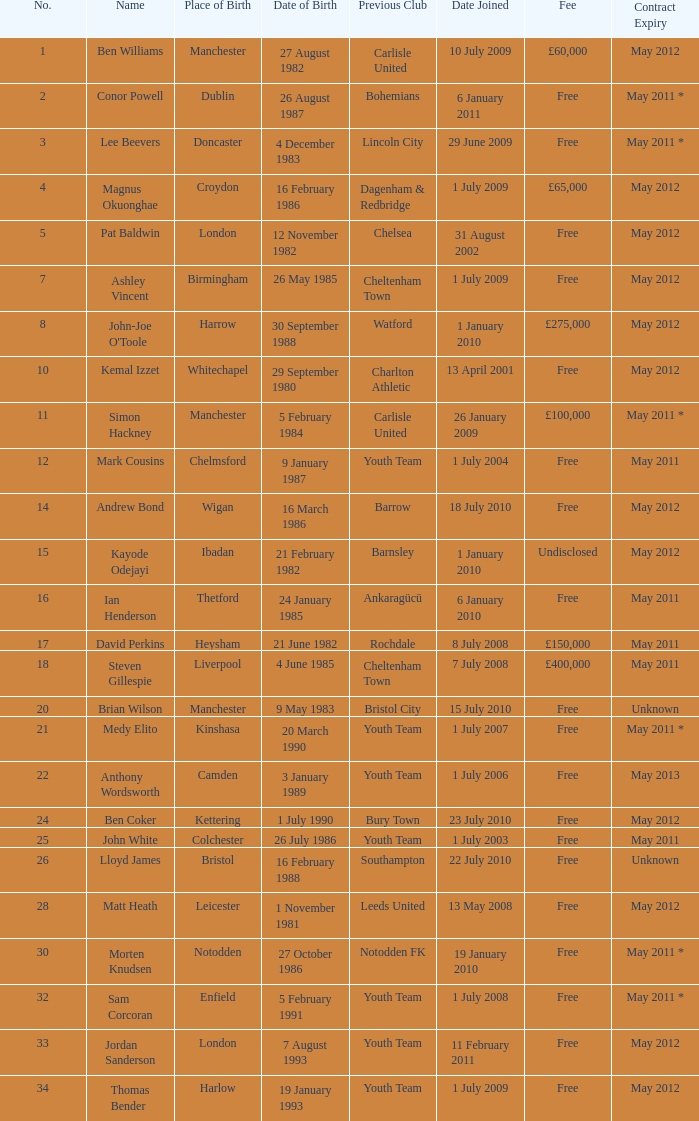How many date of birts are if the previous club is chelsea 1.0. 